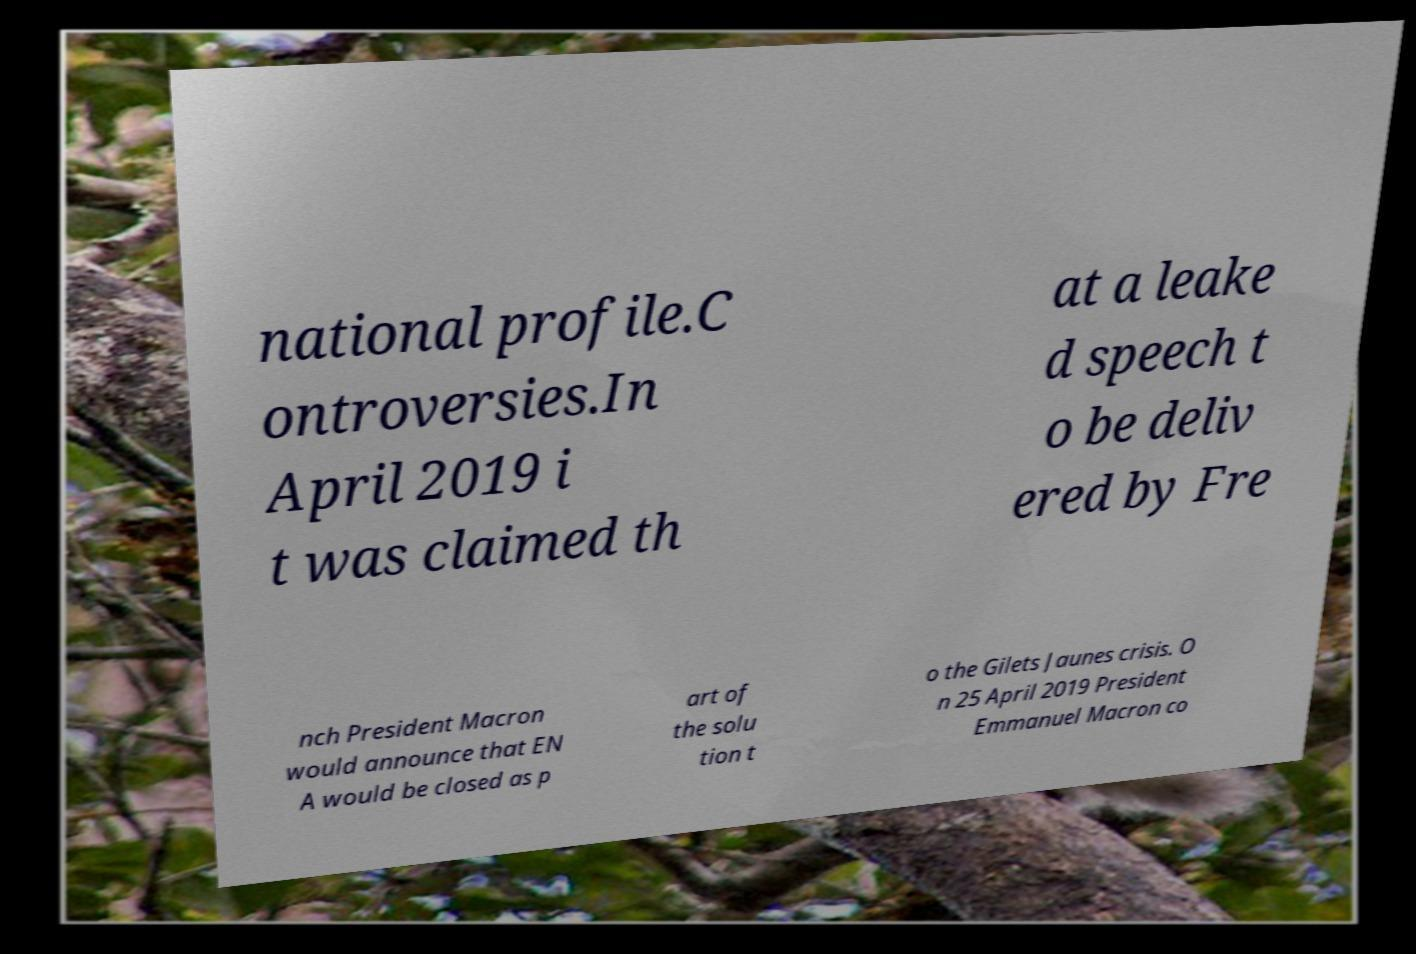Please identify and transcribe the text found in this image. national profile.C ontroversies.In April 2019 i t was claimed th at a leake d speech t o be deliv ered by Fre nch President Macron would announce that EN A would be closed as p art of the solu tion t o the Gilets Jaunes crisis. O n 25 April 2019 President Emmanuel Macron co 